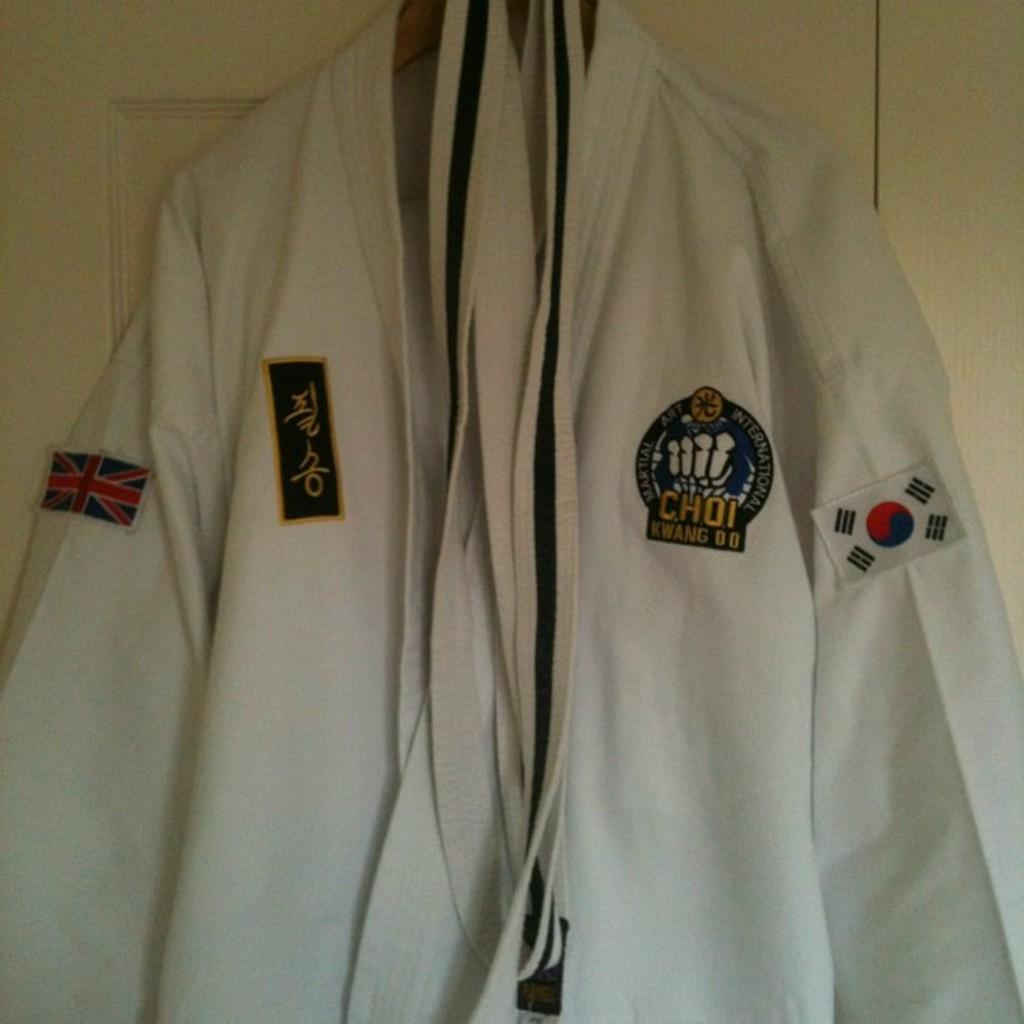What type of clothing item is present in the image? There is a coat in the image. What accessory is also visible in the image? There is a belt in the image. How are the coat and belt positioned in the image? Both the coat and belt are hanging on a hanger. What distinguishing features can be seen on the coat? There are badges attached to the coat, and they are associated with a court. What can be seen in the background of the image? There is a door in the image, and it is white in color. How many tomatoes are on the hanger with the coat and belt? There are no tomatoes present in the image; only the coat, belt, and badges are visible. What is the coat blowing in the wind in the image? The coat is not blowing in the wind in the image; it is hanging on a hanger. 